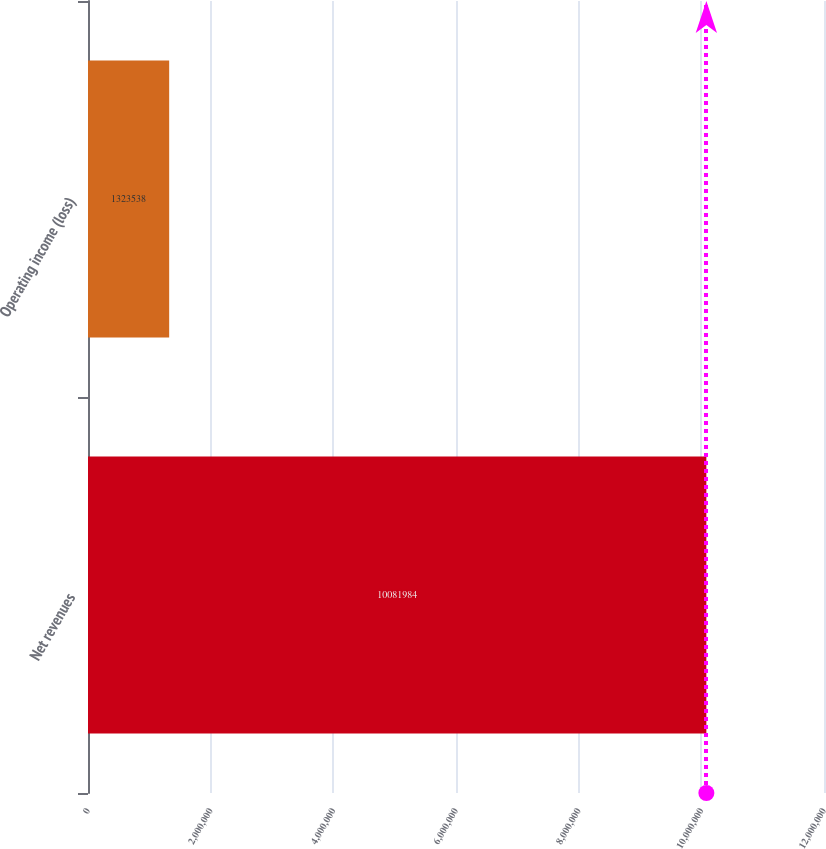Convert chart to OTSL. <chart><loc_0><loc_0><loc_500><loc_500><bar_chart><fcel>Net revenues<fcel>Operating income (loss)<nl><fcel>1.0082e+07<fcel>1.32354e+06<nl></chart> 